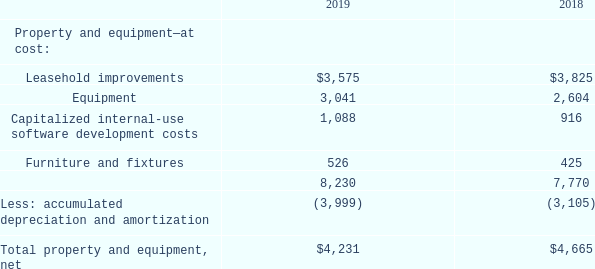Property and Equipment
Property and equipment are carried at cost. The following is a summary of property and equipment as of September 30, 2019 and 2018(amounts shown in thousands):
Depreciation and amortization of property and equipment are provided using the straight-line method over estimated useful lives ranging from three to ten
years. Leasehold improvements are amortized over the shorter of the lease term or estimated useful life of the assets. Depreciation and amortization of property and equipment totaled $1.4 million, $0.6 million, and $0.3 million for the fiscal years ended September 30, 2019, 2018, and 2017, respectively. Expenditures for repairs and maintenance are charged to operations. Total repairs and maintenance expenses were $0.1 million, $0.1 million and $0.2 million for the fiscal years ended September 30, 2019, 2018, and 2017, respectively.
What segment do expenditures for repairs and maintenance belong to? Operations. What are the total depreciation and amortization of property and equipment for the fiscal year 2018 and 2019, respectively? $0.6 million, $1.4 million. What does the table provide for us? A summary of property and equipment as of september 30, 2019 and 2018. What is the average of total repairs and maintenance expenses from 2017 to 2019?
Answer scale should be: million. (0.1+0.1+0.2)/3 
Answer: 0.13. What is the percentage change of net total property and equipment from 2018 to 2019?
Answer scale should be: percent. (4,231-4,665)/4,665 
Answer: -9.3. What is the proportion of the total value of leasehold improvements and equipment over the total value of property and equipment at cost in 2019? (3,575+3,041)/8,230 
Answer: 0.8. 